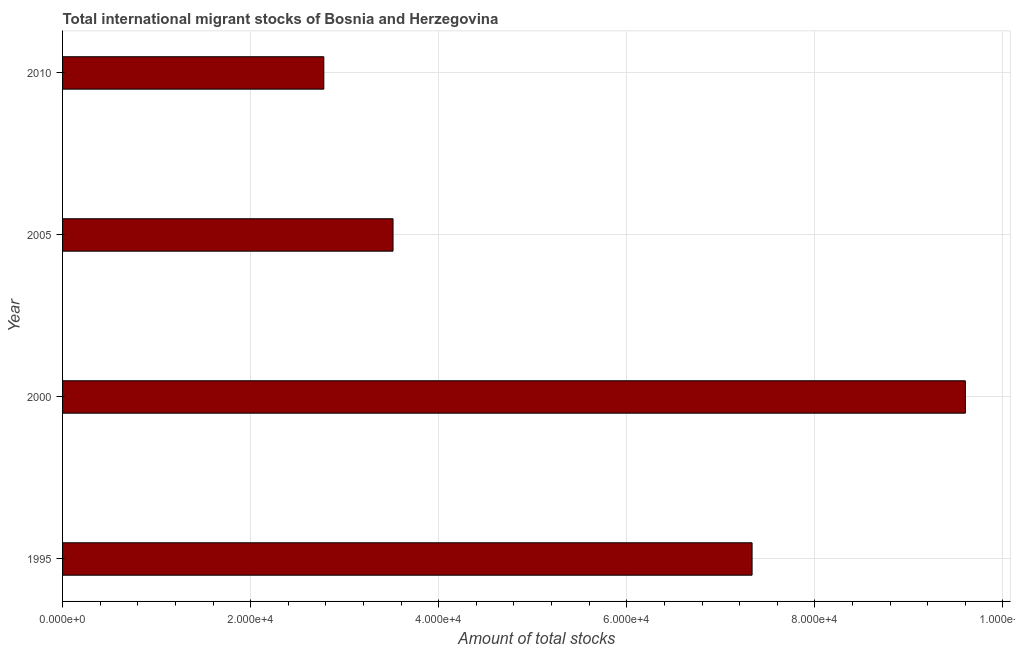Does the graph contain grids?
Make the answer very short. Yes. What is the title of the graph?
Offer a terse response. Total international migrant stocks of Bosnia and Herzegovina. What is the label or title of the X-axis?
Your response must be concise. Amount of total stocks. What is the label or title of the Y-axis?
Make the answer very short. Year. What is the total number of international migrant stock in 2010?
Make the answer very short. 2.78e+04. Across all years, what is the maximum total number of international migrant stock?
Offer a terse response. 9.60e+04. Across all years, what is the minimum total number of international migrant stock?
Provide a succinct answer. 2.78e+04. In which year was the total number of international migrant stock maximum?
Provide a succinct answer. 2000. What is the sum of the total number of international migrant stock?
Ensure brevity in your answer.  2.32e+05. What is the difference between the total number of international migrant stock in 1995 and 2005?
Offer a very short reply. 3.82e+04. What is the average total number of international migrant stock per year?
Ensure brevity in your answer.  5.81e+04. What is the median total number of international migrant stock?
Your answer should be compact. 5.42e+04. In how many years, is the total number of international migrant stock greater than 20000 ?
Keep it short and to the point. 4. What is the ratio of the total number of international migrant stock in 1995 to that in 2005?
Make the answer very short. 2.09. Is the total number of international migrant stock in 1995 less than that in 2010?
Offer a terse response. No. What is the difference between the highest and the second highest total number of international migrant stock?
Your response must be concise. 2.27e+04. What is the difference between the highest and the lowest total number of international migrant stock?
Ensure brevity in your answer.  6.82e+04. In how many years, is the total number of international migrant stock greater than the average total number of international migrant stock taken over all years?
Make the answer very short. 2. Are all the bars in the graph horizontal?
Make the answer very short. Yes. What is the difference between two consecutive major ticks on the X-axis?
Give a very brief answer. 2.00e+04. Are the values on the major ticks of X-axis written in scientific E-notation?
Ensure brevity in your answer.  Yes. What is the Amount of total stocks of 1995?
Keep it short and to the point. 7.33e+04. What is the Amount of total stocks in 2000?
Ensure brevity in your answer.  9.60e+04. What is the Amount of total stocks of 2005?
Give a very brief answer. 3.51e+04. What is the Amount of total stocks of 2010?
Keep it short and to the point. 2.78e+04. What is the difference between the Amount of total stocks in 1995 and 2000?
Your answer should be very brief. -2.27e+04. What is the difference between the Amount of total stocks in 1995 and 2005?
Your response must be concise. 3.82e+04. What is the difference between the Amount of total stocks in 1995 and 2010?
Make the answer very short. 4.55e+04. What is the difference between the Amount of total stocks in 2000 and 2005?
Ensure brevity in your answer.  6.09e+04. What is the difference between the Amount of total stocks in 2000 and 2010?
Your answer should be compact. 6.82e+04. What is the difference between the Amount of total stocks in 2005 and 2010?
Provide a succinct answer. 7361. What is the ratio of the Amount of total stocks in 1995 to that in 2000?
Provide a short and direct response. 0.76. What is the ratio of the Amount of total stocks in 1995 to that in 2005?
Offer a terse response. 2.09. What is the ratio of the Amount of total stocks in 1995 to that in 2010?
Provide a succinct answer. 2.64. What is the ratio of the Amount of total stocks in 2000 to that in 2005?
Provide a short and direct response. 2.73. What is the ratio of the Amount of total stocks in 2000 to that in 2010?
Your answer should be compact. 3.46. What is the ratio of the Amount of total stocks in 2005 to that in 2010?
Your answer should be very brief. 1.26. 